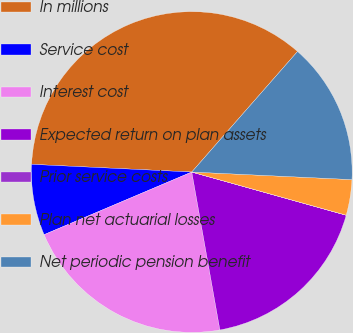Convert chart. <chart><loc_0><loc_0><loc_500><loc_500><pie_chart><fcel>In millions<fcel>Service cost<fcel>Interest cost<fcel>Expected return on plan assets<fcel>Prior service costs<fcel>Plan net actuarial losses<fcel>Net periodic pension benefit<nl><fcel>35.7%<fcel>7.15%<fcel>21.42%<fcel>17.85%<fcel>0.01%<fcel>3.58%<fcel>14.29%<nl></chart> 